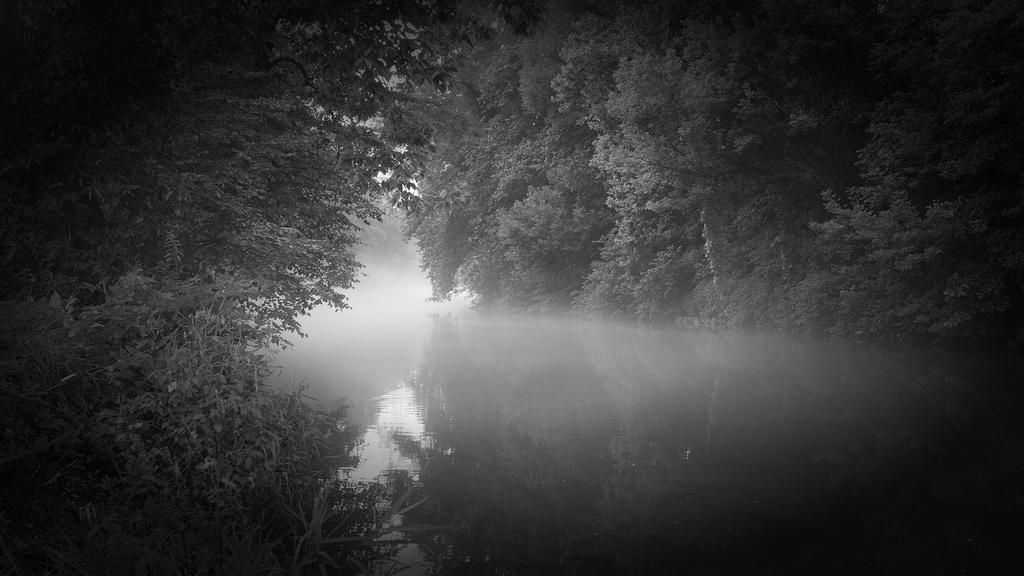What is the color scheme of the image? The image is black and white. What is the main feature in the middle of the image? There is a river in the middle of the image. What type of vegetation is present on either side of the river? There are trees on either side of the river. What type of cord is being used for the discussion in the image? There is no discussion or cord present in the image; it features a river with trees on either side. 